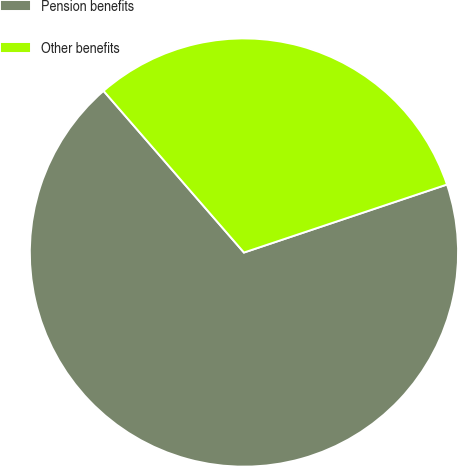Convert chart. <chart><loc_0><loc_0><loc_500><loc_500><pie_chart><fcel>Pension benefits<fcel>Other benefits<nl><fcel>68.76%<fcel>31.24%<nl></chart> 